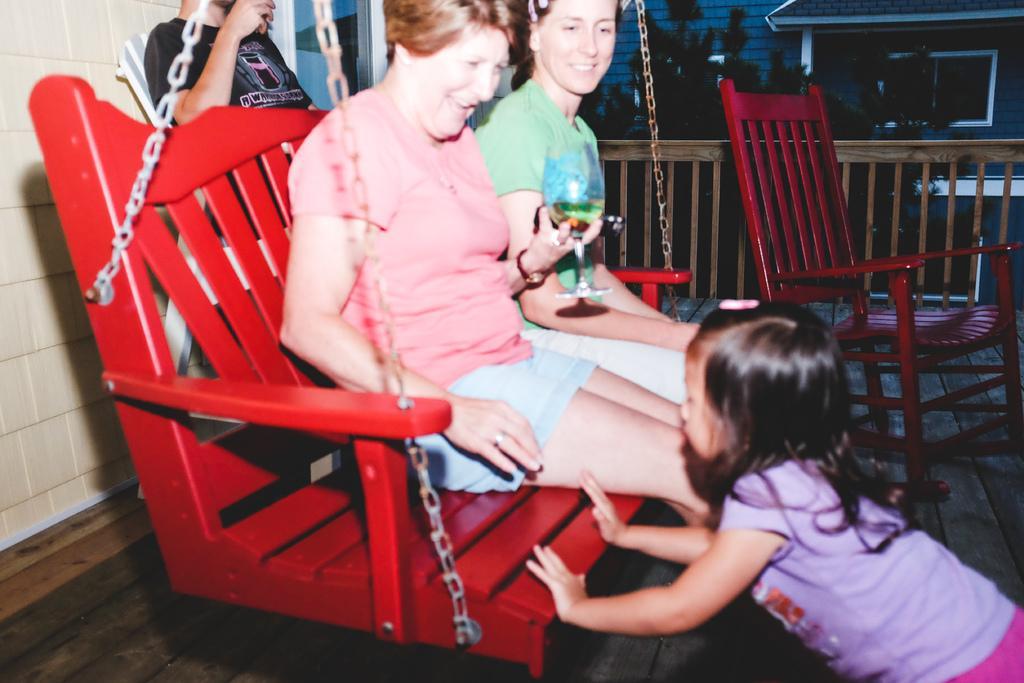Please provide a concise description of this image. This picture is of inside. On the right there is a girl standing and seems to be pushing the swing. In the center there are two women smiling and sitting on the red color swing. On the right we can see a red color chair. In the background there is a building, tree, a person sitting on the chair and the wall. 